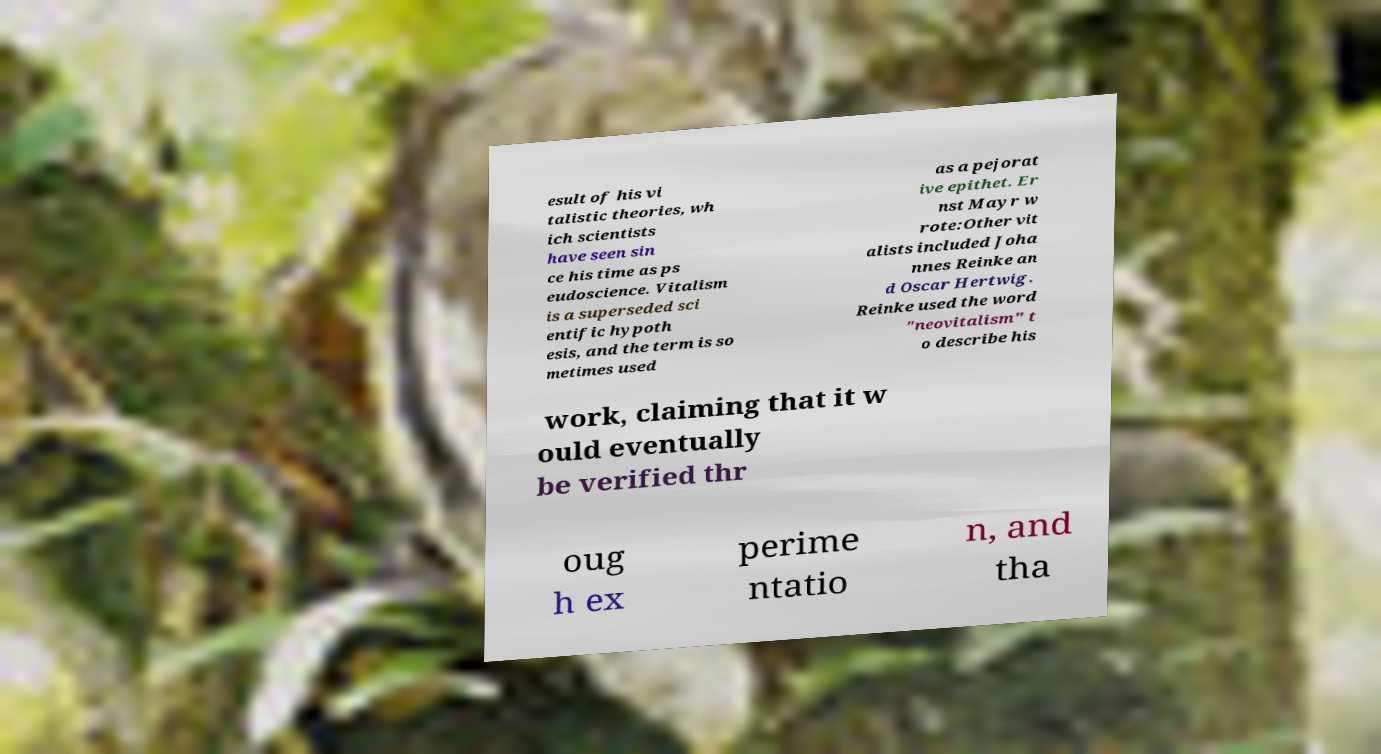For documentation purposes, I need the text within this image transcribed. Could you provide that? esult of his vi talistic theories, wh ich scientists have seen sin ce his time as ps eudoscience. Vitalism is a superseded sci entific hypoth esis, and the term is so metimes used as a pejorat ive epithet. Er nst Mayr w rote:Other vit alists included Joha nnes Reinke an d Oscar Hertwig. Reinke used the word "neovitalism" t o describe his work, claiming that it w ould eventually be verified thr oug h ex perime ntatio n, and tha 